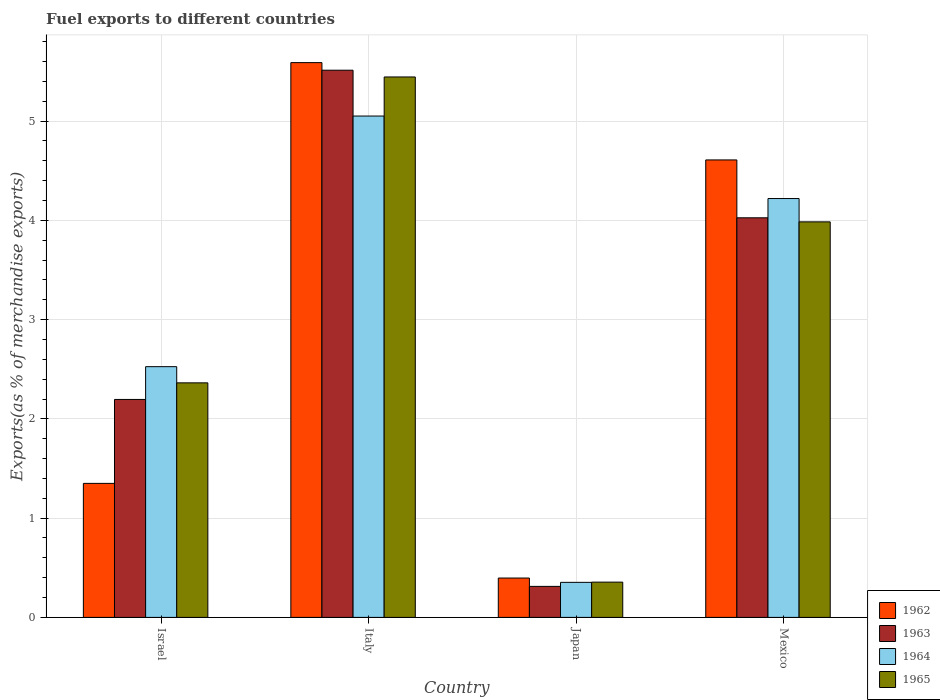Are the number of bars on each tick of the X-axis equal?
Provide a succinct answer. Yes. How many bars are there on the 1st tick from the left?
Give a very brief answer. 4. What is the label of the 3rd group of bars from the left?
Provide a succinct answer. Japan. In how many cases, is the number of bars for a given country not equal to the number of legend labels?
Provide a short and direct response. 0. What is the percentage of exports to different countries in 1962 in Japan?
Make the answer very short. 0.4. Across all countries, what is the maximum percentage of exports to different countries in 1964?
Ensure brevity in your answer.  5.05. Across all countries, what is the minimum percentage of exports to different countries in 1963?
Your answer should be compact. 0.31. What is the total percentage of exports to different countries in 1963 in the graph?
Your response must be concise. 12.05. What is the difference between the percentage of exports to different countries in 1965 in Israel and that in Mexico?
Offer a terse response. -1.62. What is the difference between the percentage of exports to different countries in 1962 in Mexico and the percentage of exports to different countries in 1964 in Japan?
Make the answer very short. 4.26. What is the average percentage of exports to different countries in 1964 per country?
Give a very brief answer. 3.04. What is the difference between the percentage of exports to different countries of/in 1963 and percentage of exports to different countries of/in 1962 in Mexico?
Your answer should be compact. -0.58. In how many countries, is the percentage of exports to different countries in 1962 greater than 3.4 %?
Offer a very short reply. 2. What is the ratio of the percentage of exports to different countries in 1965 in Italy to that in Japan?
Your answer should be compact. 15.32. Is the percentage of exports to different countries in 1965 in Israel less than that in Italy?
Provide a short and direct response. Yes. What is the difference between the highest and the second highest percentage of exports to different countries in 1965?
Make the answer very short. -1.62. What is the difference between the highest and the lowest percentage of exports to different countries in 1963?
Make the answer very short. 5.2. In how many countries, is the percentage of exports to different countries in 1962 greater than the average percentage of exports to different countries in 1962 taken over all countries?
Ensure brevity in your answer.  2. What does the 4th bar from the left in Israel represents?
Your response must be concise. 1965. What does the 2nd bar from the right in Israel represents?
Your answer should be very brief. 1964. Are all the bars in the graph horizontal?
Provide a succinct answer. No. How many countries are there in the graph?
Offer a terse response. 4. What is the title of the graph?
Provide a short and direct response. Fuel exports to different countries. What is the label or title of the X-axis?
Your answer should be very brief. Country. What is the label or title of the Y-axis?
Provide a short and direct response. Exports(as % of merchandise exports). What is the Exports(as % of merchandise exports) in 1962 in Israel?
Make the answer very short. 1.35. What is the Exports(as % of merchandise exports) in 1963 in Israel?
Your answer should be compact. 2.2. What is the Exports(as % of merchandise exports) of 1964 in Israel?
Give a very brief answer. 2.53. What is the Exports(as % of merchandise exports) in 1965 in Israel?
Your response must be concise. 2.36. What is the Exports(as % of merchandise exports) of 1962 in Italy?
Provide a short and direct response. 5.59. What is the Exports(as % of merchandise exports) in 1963 in Italy?
Provide a short and direct response. 5.51. What is the Exports(as % of merchandise exports) in 1964 in Italy?
Give a very brief answer. 5.05. What is the Exports(as % of merchandise exports) of 1965 in Italy?
Give a very brief answer. 5.45. What is the Exports(as % of merchandise exports) of 1962 in Japan?
Make the answer very short. 0.4. What is the Exports(as % of merchandise exports) of 1963 in Japan?
Provide a succinct answer. 0.31. What is the Exports(as % of merchandise exports) of 1964 in Japan?
Give a very brief answer. 0.35. What is the Exports(as % of merchandise exports) of 1965 in Japan?
Your answer should be compact. 0.36. What is the Exports(as % of merchandise exports) of 1962 in Mexico?
Provide a succinct answer. 4.61. What is the Exports(as % of merchandise exports) in 1963 in Mexico?
Offer a terse response. 4.03. What is the Exports(as % of merchandise exports) in 1964 in Mexico?
Keep it short and to the point. 4.22. What is the Exports(as % of merchandise exports) of 1965 in Mexico?
Make the answer very short. 3.99. Across all countries, what is the maximum Exports(as % of merchandise exports) in 1962?
Your answer should be very brief. 5.59. Across all countries, what is the maximum Exports(as % of merchandise exports) of 1963?
Provide a succinct answer. 5.51. Across all countries, what is the maximum Exports(as % of merchandise exports) of 1964?
Offer a very short reply. 5.05. Across all countries, what is the maximum Exports(as % of merchandise exports) in 1965?
Your answer should be compact. 5.45. Across all countries, what is the minimum Exports(as % of merchandise exports) of 1962?
Make the answer very short. 0.4. Across all countries, what is the minimum Exports(as % of merchandise exports) of 1963?
Your answer should be compact. 0.31. Across all countries, what is the minimum Exports(as % of merchandise exports) of 1964?
Ensure brevity in your answer.  0.35. Across all countries, what is the minimum Exports(as % of merchandise exports) in 1965?
Offer a terse response. 0.36. What is the total Exports(as % of merchandise exports) of 1962 in the graph?
Your response must be concise. 11.95. What is the total Exports(as % of merchandise exports) in 1963 in the graph?
Keep it short and to the point. 12.05. What is the total Exports(as % of merchandise exports) of 1964 in the graph?
Offer a very short reply. 12.15. What is the total Exports(as % of merchandise exports) in 1965 in the graph?
Offer a very short reply. 12.15. What is the difference between the Exports(as % of merchandise exports) in 1962 in Israel and that in Italy?
Your response must be concise. -4.24. What is the difference between the Exports(as % of merchandise exports) of 1963 in Israel and that in Italy?
Provide a succinct answer. -3.32. What is the difference between the Exports(as % of merchandise exports) of 1964 in Israel and that in Italy?
Provide a succinct answer. -2.53. What is the difference between the Exports(as % of merchandise exports) in 1965 in Israel and that in Italy?
Your answer should be compact. -3.08. What is the difference between the Exports(as % of merchandise exports) of 1962 in Israel and that in Japan?
Ensure brevity in your answer.  0.95. What is the difference between the Exports(as % of merchandise exports) in 1963 in Israel and that in Japan?
Give a very brief answer. 1.88. What is the difference between the Exports(as % of merchandise exports) of 1964 in Israel and that in Japan?
Offer a very short reply. 2.17. What is the difference between the Exports(as % of merchandise exports) of 1965 in Israel and that in Japan?
Your answer should be very brief. 2.01. What is the difference between the Exports(as % of merchandise exports) of 1962 in Israel and that in Mexico?
Your answer should be compact. -3.26. What is the difference between the Exports(as % of merchandise exports) in 1963 in Israel and that in Mexico?
Your response must be concise. -1.83. What is the difference between the Exports(as % of merchandise exports) in 1964 in Israel and that in Mexico?
Provide a succinct answer. -1.69. What is the difference between the Exports(as % of merchandise exports) of 1965 in Israel and that in Mexico?
Ensure brevity in your answer.  -1.62. What is the difference between the Exports(as % of merchandise exports) of 1962 in Italy and that in Japan?
Make the answer very short. 5.19. What is the difference between the Exports(as % of merchandise exports) in 1963 in Italy and that in Japan?
Provide a short and direct response. 5.2. What is the difference between the Exports(as % of merchandise exports) of 1964 in Italy and that in Japan?
Offer a terse response. 4.7. What is the difference between the Exports(as % of merchandise exports) in 1965 in Italy and that in Japan?
Provide a short and direct response. 5.09. What is the difference between the Exports(as % of merchandise exports) of 1962 in Italy and that in Mexico?
Offer a terse response. 0.98. What is the difference between the Exports(as % of merchandise exports) of 1963 in Italy and that in Mexico?
Your answer should be very brief. 1.49. What is the difference between the Exports(as % of merchandise exports) of 1964 in Italy and that in Mexico?
Provide a succinct answer. 0.83. What is the difference between the Exports(as % of merchandise exports) in 1965 in Italy and that in Mexico?
Your response must be concise. 1.46. What is the difference between the Exports(as % of merchandise exports) in 1962 in Japan and that in Mexico?
Offer a terse response. -4.21. What is the difference between the Exports(as % of merchandise exports) of 1963 in Japan and that in Mexico?
Offer a terse response. -3.71. What is the difference between the Exports(as % of merchandise exports) in 1964 in Japan and that in Mexico?
Provide a short and direct response. -3.87. What is the difference between the Exports(as % of merchandise exports) in 1965 in Japan and that in Mexico?
Provide a short and direct response. -3.63. What is the difference between the Exports(as % of merchandise exports) of 1962 in Israel and the Exports(as % of merchandise exports) of 1963 in Italy?
Provide a succinct answer. -4.16. What is the difference between the Exports(as % of merchandise exports) in 1962 in Israel and the Exports(as % of merchandise exports) in 1964 in Italy?
Keep it short and to the point. -3.7. What is the difference between the Exports(as % of merchandise exports) of 1962 in Israel and the Exports(as % of merchandise exports) of 1965 in Italy?
Make the answer very short. -4.09. What is the difference between the Exports(as % of merchandise exports) of 1963 in Israel and the Exports(as % of merchandise exports) of 1964 in Italy?
Make the answer very short. -2.86. What is the difference between the Exports(as % of merchandise exports) of 1963 in Israel and the Exports(as % of merchandise exports) of 1965 in Italy?
Make the answer very short. -3.25. What is the difference between the Exports(as % of merchandise exports) in 1964 in Israel and the Exports(as % of merchandise exports) in 1965 in Italy?
Provide a short and direct response. -2.92. What is the difference between the Exports(as % of merchandise exports) in 1962 in Israel and the Exports(as % of merchandise exports) in 1963 in Japan?
Ensure brevity in your answer.  1.04. What is the difference between the Exports(as % of merchandise exports) of 1962 in Israel and the Exports(as % of merchandise exports) of 1964 in Japan?
Your answer should be very brief. 1. What is the difference between the Exports(as % of merchandise exports) in 1963 in Israel and the Exports(as % of merchandise exports) in 1964 in Japan?
Make the answer very short. 1.84. What is the difference between the Exports(as % of merchandise exports) in 1963 in Israel and the Exports(as % of merchandise exports) in 1965 in Japan?
Ensure brevity in your answer.  1.84. What is the difference between the Exports(as % of merchandise exports) of 1964 in Israel and the Exports(as % of merchandise exports) of 1965 in Japan?
Your response must be concise. 2.17. What is the difference between the Exports(as % of merchandise exports) of 1962 in Israel and the Exports(as % of merchandise exports) of 1963 in Mexico?
Your answer should be compact. -2.68. What is the difference between the Exports(as % of merchandise exports) in 1962 in Israel and the Exports(as % of merchandise exports) in 1964 in Mexico?
Your response must be concise. -2.87. What is the difference between the Exports(as % of merchandise exports) in 1962 in Israel and the Exports(as % of merchandise exports) in 1965 in Mexico?
Your response must be concise. -2.63. What is the difference between the Exports(as % of merchandise exports) in 1963 in Israel and the Exports(as % of merchandise exports) in 1964 in Mexico?
Ensure brevity in your answer.  -2.02. What is the difference between the Exports(as % of merchandise exports) in 1963 in Israel and the Exports(as % of merchandise exports) in 1965 in Mexico?
Your response must be concise. -1.79. What is the difference between the Exports(as % of merchandise exports) in 1964 in Israel and the Exports(as % of merchandise exports) in 1965 in Mexico?
Give a very brief answer. -1.46. What is the difference between the Exports(as % of merchandise exports) in 1962 in Italy and the Exports(as % of merchandise exports) in 1963 in Japan?
Ensure brevity in your answer.  5.28. What is the difference between the Exports(as % of merchandise exports) of 1962 in Italy and the Exports(as % of merchandise exports) of 1964 in Japan?
Your response must be concise. 5.24. What is the difference between the Exports(as % of merchandise exports) of 1962 in Italy and the Exports(as % of merchandise exports) of 1965 in Japan?
Offer a very short reply. 5.23. What is the difference between the Exports(as % of merchandise exports) of 1963 in Italy and the Exports(as % of merchandise exports) of 1964 in Japan?
Offer a terse response. 5.16. What is the difference between the Exports(as % of merchandise exports) of 1963 in Italy and the Exports(as % of merchandise exports) of 1965 in Japan?
Offer a very short reply. 5.16. What is the difference between the Exports(as % of merchandise exports) of 1964 in Italy and the Exports(as % of merchandise exports) of 1965 in Japan?
Offer a very short reply. 4.7. What is the difference between the Exports(as % of merchandise exports) in 1962 in Italy and the Exports(as % of merchandise exports) in 1963 in Mexico?
Make the answer very short. 1.56. What is the difference between the Exports(as % of merchandise exports) in 1962 in Italy and the Exports(as % of merchandise exports) in 1964 in Mexico?
Provide a short and direct response. 1.37. What is the difference between the Exports(as % of merchandise exports) of 1962 in Italy and the Exports(as % of merchandise exports) of 1965 in Mexico?
Keep it short and to the point. 1.6. What is the difference between the Exports(as % of merchandise exports) of 1963 in Italy and the Exports(as % of merchandise exports) of 1964 in Mexico?
Ensure brevity in your answer.  1.29. What is the difference between the Exports(as % of merchandise exports) in 1963 in Italy and the Exports(as % of merchandise exports) in 1965 in Mexico?
Your answer should be compact. 1.53. What is the difference between the Exports(as % of merchandise exports) of 1964 in Italy and the Exports(as % of merchandise exports) of 1965 in Mexico?
Give a very brief answer. 1.07. What is the difference between the Exports(as % of merchandise exports) in 1962 in Japan and the Exports(as % of merchandise exports) in 1963 in Mexico?
Your answer should be very brief. -3.63. What is the difference between the Exports(as % of merchandise exports) of 1962 in Japan and the Exports(as % of merchandise exports) of 1964 in Mexico?
Provide a short and direct response. -3.82. What is the difference between the Exports(as % of merchandise exports) in 1962 in Japan and the Exports(as % of merchandise exports) in 1965 in Mexico?
Your answer should be compact. -3.59. What is the difference between the Exports(as % of merchandise exports) in 1963 in Japan and the Exports(as % of merchandise exports) in 1964 in Mexico?
Your answer should be compact. -3.91. What is the difference between the Exports(as % of merchandise exports) in 1963 in Japan and the Exports(as % of merchandise exports) in 1965 in Mexico?
Your answer should be compact. -3.67. What is the difference between the Exports(as % of merchandise exports) in 1964 in Japan and the Exports(as % of merchandise exports) in 1965 in Mexico?
Give a very brief answer. -3.63. What is the average Exports(as % of merchandise exports) of 1962 per country?
Give a very brief answer. 2.99. What is the average Exports(as % of merchandise exports) of 1963 per country?
Give a very brief answer. 3.01. What is the average Exports(as % of merchandise exports) in 1964 per country?
Your answer should be very brief. 3.04. What is the average Exports(as % of merchandise exports) of 1965 per country?
Provide a short and direct response. 3.04. What is the difference between the Exports(as % of merchandise exports) of 1962 and Exports(as % of merchandise exports) of 1963 in Israel?
Keep it short and to the point. -0.85. What is the difference between the Exports(as % of merchandise exports) of 1962 and Exports(as % of merchandise exports) of 1964 in Israel?
Provide a succinct answer. -1.18. What is the difference between the Exports(as % of merchandise exports) of 1962 and Exports(as % of merchandise exports) of 1965 in Israel?
Your response must be concise. -1.01. What is the difference between the Exports(as % of merchandise exports) of 1963 and Exports(as % of merchandise exports) of 1964 in Israel?
Provide a short and direct response. -0.33. What is the difference between the Exports(as % of merchandise exports) in 1963 and Exports(as % of merchandise exports) in 1965 in Israel?
Give a very brief answer. -0.17. What is the difference between the Exports(as % of merchandise exports) of 1964 and Exports(as % of merchandise exports) of 1965 in Israel?
Keep it short and to the point. 0.16. What is the difference between the Exports(as % of merchandise exports) in 1962 and Exports(as % of merchandise exports) in 1963 in Italy?
Offer a terse response. 0.08. What is the difference between the Exports(as % of merchandise exports) of 1962 and Exports(as % of merchandise exports) of 1964 in Italy?
Your answer should be compact. 0.54. What is the difference between the Exports(as % of merchandise exports) of 1962 and Exports(as % of merchandise exports) of 1965 in Italy?
Offer a very short reply. 0.14. What is the difference between the Exports(as % of merchandise exports) in 1963 and Exports(as % of merchandise exports) in 1964 in Italy?
Provide a short and direct response. 0.46. What is the difference between the Exports(as % of merchandise exports) in 1963 and Exports(as % of merchandise exports) in 1965 in Italy?
Your answer should be very brief. 0.07. What is the difference between the Exports(as % of merchandise exports) of 1964 and Exports(as % of merchandise exports) of 1965 in Italy?
Offer a terse response. -0.39. What is the difference between the Exports(as % of merchandise exports) of 1962 and Exports(as % of merchandise exports) of 1963 in Japan?
Your answer should be compact. 0.08. What is the difference between the Exports(as % of merchandise exports) of 1962 and Exports(as % of merchandise exports) of 1964 in Japan?
Your answer should be very brief. 0.04. What is the difference between the Exports(as % of merchandise exports) in 1962 and Exports(as % of merchandise exports) in 1965 in Japan?
Your answer should be very brief. 0.04. What is the difference between the Exports(as % of merchandise exports) in 1963 and Exports(as % of merchandise exports) in 1964 in Japan?
Your answer should be very brief. -0.04. What is the difference between the Exports(as % of merchandise exports) in 1963 and Exports(as % of merchandise exports) in 1965 in Japan?
Offer a very short reply. -0.04. What is the difference between the Exports(as % of merchandise exports) in 1964 and Exports(as % of merchandise exports) in 1965 in Japan?
Offer a terse response. -0. What is the difference between the Exports(as % of merchandise exports) in 1962 and Exports(as % of merchandise exports) in 1963 in Mexico?
Keep it short and to the point. 0.58. What is the difference between the Exports(as % of merchandise exports) in 1962 and Exports(as % of merchandise exports) in 1964 in Mexico?
Your answer should be compact. 0.39. What is the difference between the Exports(as % of merchandise exports) in 1962 and Exports(as % of merchandise exports) in 1965 in Mexico?
Provide a short and direct response. 0.62. What is the difference between the Exports(as % of merchandise exports) in 1963 and Exports(as % of merchandise exports) in 1964 in Mexico?
Provide a short and direct response. -0.19. What is the difference between the Exports(as % of merchandise exports) in 1963 and Exports(as % of merchandise exports) in 1965 in Mexico?
Your answer should be very brief. 0.04. What is the difference between the Exports(as % of merchandise exports) in 1964 and Exports(as % of merchandise exports) in 1965 in Mexico?
Give a very brief answer. 0.23. What is the ratio of the Exports(as % of merchandise exports) of 1962 in Israel to that in Italy?
Your answer should be very brief. 0.24. What is the ratio of the Exports(as % of merchandise exports) in 1963 in Israel to that in Italy?
Your answer should be very brief. 0.4. What is the ratio of the Exports(as % of merchandise exports) of 1964 in Israel to that in Italy?
Offer a terse response. 0.5. What is the ratio of the Exports(as % of merchandise exports) in 1965 in Israel to that in Italy?
Provide a short and direct response. 0.43. What is the ratio of the Exports(as % of merchandise exports) of 1962 in Israel to that in Japan?
Your response must be concise. 3.4. What is the ratio of the Exports(as % of merchandise exports) of 1963 in Israel to that in Japan?
Your response must be concise. 7.03. What is the ratio of the Exports(as % of merchandise exports) in 1964 in Israel to that in Japan?
Provide a succinct answer. 7.16. What is the ratio of the Exports(as % of merchandise exports) of 1965 in Israel to that in Japan?
Offer a very short reply. 6.65. What is the ratio of the Exports(as % of merchandise exports) in 1962 in Israel to that in Mexico?
Provide a short and direct response. 0.29. What is the ratio of the Exports(as % of merchandise exports) of 1963 in Israel to that in Mexico?
Provide a short and direct response. 0.55. What is the ratio of the Exports(as % of merchandise exports) of 1964 in Israel to that in Mexico?
Offer a very short reply. 0.6. What is the ratio of the Exports(as % of merchandise exports) in 1965 in Israel to that in Mexico?
Your answer should be compact. 0.59. What is the ratio of the Exports(as % of merchandise exports) of 1962 in Italy to that in Japan?
Your response must be concise. 14.1. What is the ratio of the Exports(as % of merchandise exports) in 1963 in Italy to that in Japan?
Make the answer very short. 17.64. What is the ratio of the Exports(as % of merchandise exports) in 1964 in Italy to that in Japan?
Provide a short and direct response. 14.31. What is the ratio of the Exports(as % of merchandise exports) of 1965 in Italy to that in Japan?
Offer a very short reply. 15.32. What is the ratio of the Exports(as % of merchandise exports) in 1962 in Italy to that in Mexico?
Provide a short and direct response. 1.21. What is the ratio of the Exports(as % of merchandise exports) of 1963 in Italy to that in Mexico?
Your answer should be compact. 1.37. What is the ratio of the Exports(as % of merchandise exports) of 1964 in Italy to that in Mexico?
Provide a succinct answer. 1.2. What is the ratio of the Exports(as % of merchandise exports) of 1965 in Italy to that in Mexico?
Give a very brief answer. 1.37. What is the ratio of the Exports(as % of merchandise exports) in 1962 in Japan to that in Mexico?
Provide a succinct answer. 0.09. What is the ratio of the Exports(as % of merchandise exports) in 1963 in Japan to that in Mexico?
Provide a succinct answer. 0.08. What is the ratio of the Exports(as % of merchandise exports) in 1964 in Japan to that in Mexico?
Make the answer very short. 0.08. What is the ratio of the Exports(as % of merchandise exports) of 1965 in Japan to that in Mexico?
Provide a succinct answer. 0.09. What is the difference between the highest and the second highest Exports(as % of merchandise exports) in 1962?
Your answer should be very brief. 0.98. What is the difference between the highest and the second highest Exports(as % of merchandise exports) of 1963?
Your response must be concise. 1.49. What is the difference between the highest and the second highest Exports(as % of merchandise exports) of 1964?
Provide a short and direct response. 0.83. What is the difference between the highest and the second highest Exports(as % of merchandise exports) in 1965?
Keep it short and to the point. 1.46. What is the difference between the highest and the lowest Exports(as % of merchandise exports) in 1962?
Offer a very short reply. 5.19. What is the difference between the highest and the lowest Exports(as % of merchandise exports) in 1963?
Offer a very short reply. 5.2. What is the difference between the highest and the lowest Exports(as % of merchandise exports) of 1964?
Ensure brevity in your answer.  4.7. What is the difference between the highest and the lowest Exports(as % of merchandise exports) in 1965?
Your answer should be compact. 5.09. 